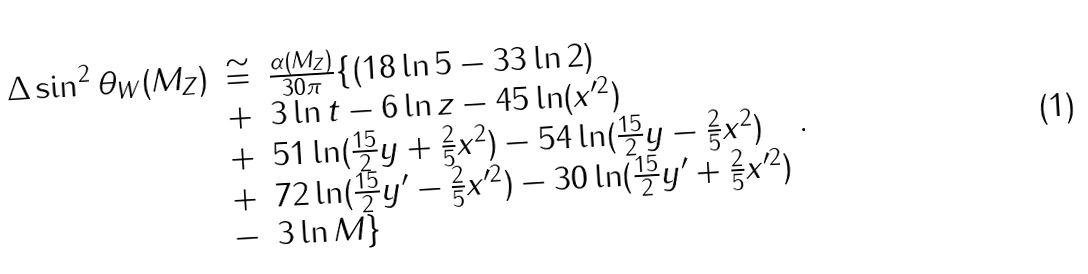Convert formula to latex. <formula><loc_0><loc_0><loc_500><loc_500>\begin{array} { r c l } \Delta \sin ^ { 2 } \theta _ { W } ( M _ { Z } ) & \cong & \frac { \alpha ( M _ { Z } ) } { 3 0 \pi } \{ ( 1 8 \ln 5 - 3 3 \ln 2 ) \strut \\ & + & 3 \ln t - 6 \ln z - 4 5 \ln ( x ^ { \prime 2 } ) \strut \\ & + & 5 1 \ln ( \frac { 1 5 } { 2 } y + \frac { 2 } { 5 } x ^ { 2 } ) - 5 4 \ln ( \frac { 1 5 } { 2 } y - \frac { 2 } { 5 } x ^ { 2 } ) \strut \\ & + & 7 2 \ln ( \frac { 1 5 } { 2 } y ^ { \prime } - \frac { 2 } { 5 } x ^ { \prime 2 } ) - 3 0 \ln ( \frac { 1 5 } { 2 } y ^ { \prime } + \frac { 2 } { 5 } x ^ { \prime 2 } ) \strut \\ & - & 3 \ln M \} \end{array} .</formula> 